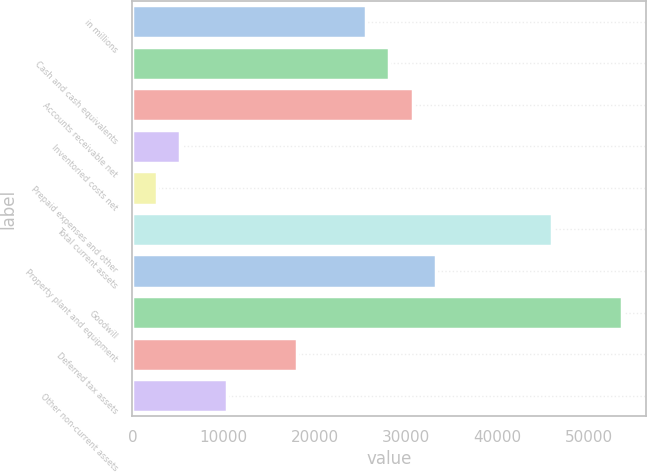Convert chart. <chart><loc_0><loc_0><loc_500><loc_500><bar_chart><fcel>in millions<fcel>Cash and cash equivalents<fcel>Accounts receivable net<fcel>Inventoried costs net<fcel>Prepaid expenses and other<fcel>Total current assets<fcel>Property plant and equipment<fcel>Goodwill<fcel>Deferred tax assets<fcel>Other non-current assets<nl><fcel>25614<fcel>28157.9<fcel>30701.8<fcel>5262.8<fcel>2718.9<fcel>45965.2<fcel>33245.7<fcel>53596.9<fcel>17982.3<fcel>10350.6<nl></chart> 